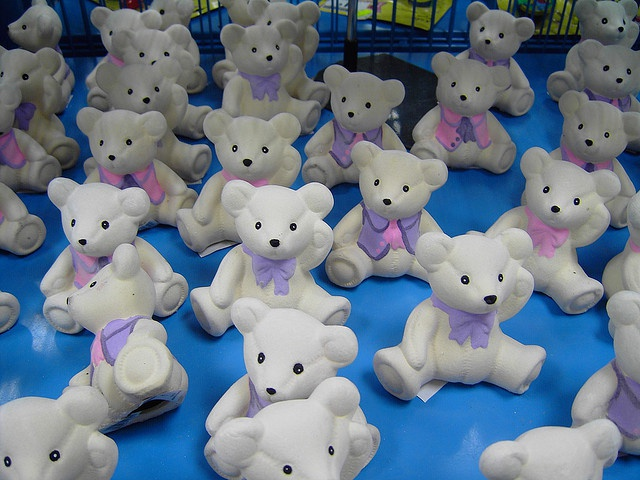Describe the objects in this image and their specific colors. I can see teddy bear in black, darkgray, lightgray, and gray tones, teddy bear in black, darkgray, lightgray, and gray tones, teddy bear in black, gray, and navy tones, teddy bear in black, darkgray, lightgray, and gray tones, and teddy bear in black, darkgray, gray, and violet tones in this image. 